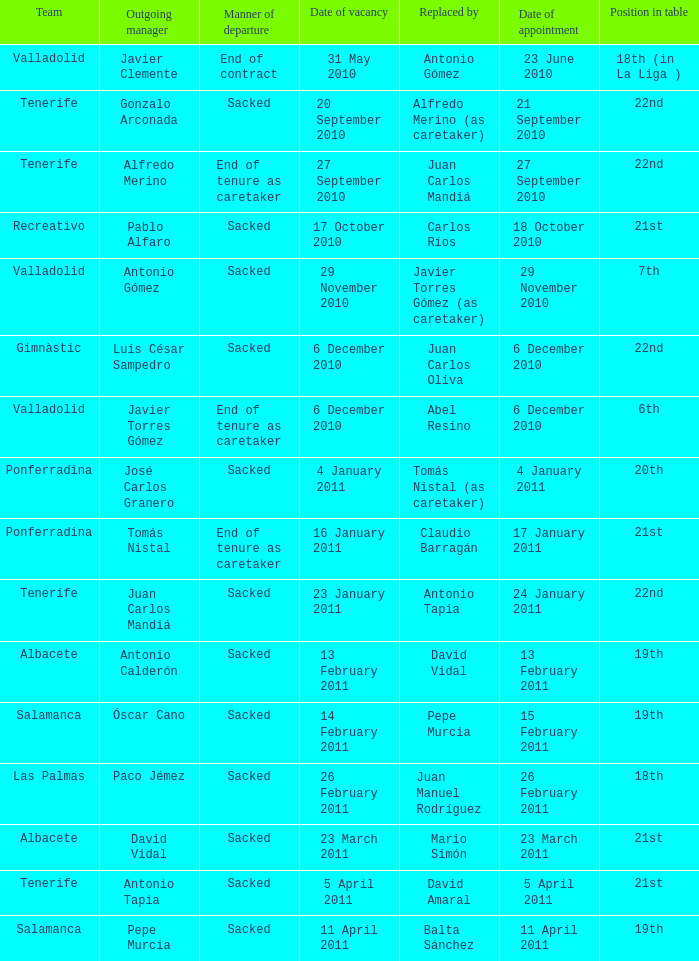What was the position of appointment date 17 january 2011 21st. 